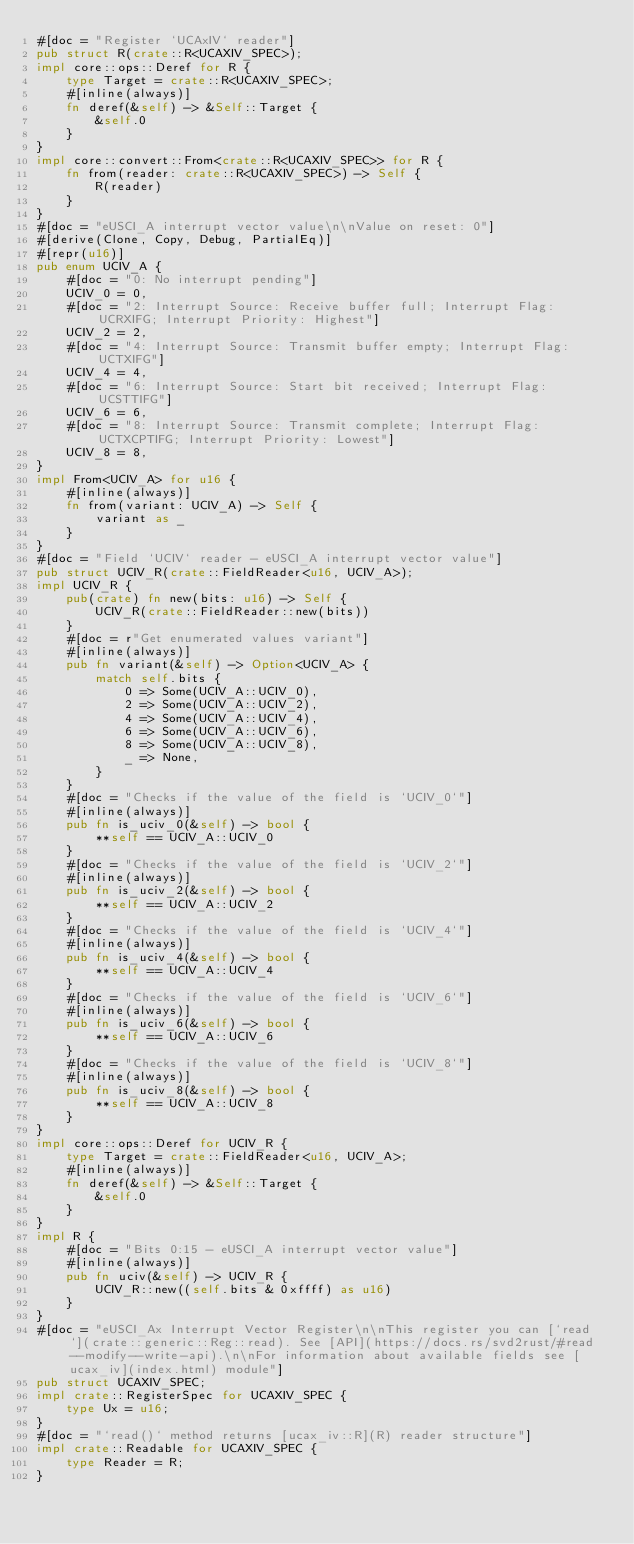Convert code to text. <code><loc_0><loc_0><loc_500><loc_500><_Rust_>#[doc = "Register `UCAxIV` reader"]
pub struct R(crate::R<UCAXIV_SPEC>);
impl core::ops::Deref for R {
    type Target = crate::R<UCAXIV_SPEC>;
    #[inline(always)]
    fn deref(&self) -> &Self::Target {
        &self.0
    }
}
impl core::convert::From<crate::R<UCAXIV_SPEC>> for R {
    fn from(reader: crate::R<UCAXIV_SPEC>) -> Self {
        R(reader)
    }
}
#[doc = "eUSCI_A interrupt vector value\n\nValue on reset: 0"]
#[derive(Clone, Copy, Debug, PartialEq)]
#[repr(u16)]
pub enum UCIV_A {
    #[doc = "0: No interrupt pending"]
    UCIV_0 = 0,
    #[doc = "2: Interrupt Source: Receive buffer full; Interrupt Flag: UCRXIFG; Interrupt Priority: Highest"]
    UCIV_2 = 2,
    #[doc = "4: Interrupt Source: Transmit buffer empty; Interrupt Flag: UCTXIFG"]
    UCIV_4 = 4,
    #[doc = "6: Interrupt Source: Start bit received; Interrupt Flag: UCSTTIFG"]
    UCIV_6 = 6,
    #[doc = "8: Interrupt Source: Transmit complete; Interrupt Flag: UCTXCPTIFG; Interrupt Priority: Lowest"]
    UCIV_8 = 8,
}
impl From<UCIV_A> for u16 {
    #[inline(always)]
    fn from(variant: UCIV_A) -> Self {
        variant as _
    }
}
#[doc = "Field `UCIV` reader - eUSCI_A interrupt vector value"]
pub struct UCIV_R(crate::FieldReader<u16, UCIV_A>);
impl UCIV_R {
    pub(crate) fn new(bits: u16) -> Self {
        UCIV_R(crate::FieldReader::new(bits))
    }
    #[doc = r"Get enumerated values variant"]
    #[inline(always)]
    pub fn variant(&self) -> Option<UCIV_A> {
        match self.bits {
            0 => Some(UCIV_A::UCIV_0),
            2 => Some(UCIV_A::UCIV_2),
            4 => Some(UCIV_A::UCIV_4),
            6 => Some(UCIV_A::UCIV_6),
            8 => Some(UCIV_A::UCIV_8),
            _ => None,
        }
    }
    #[doc = "Checks if the value of the field is `UCIV_0`"]
    #[inline(always)]
    pub fn is_uciv_0(&self) -> bool {
        **self == UCIV_A::UCIV_0
    }
    #[doc = "Checks if the value of the field is `UCIV_2`"]
    #[inline(always)]
    pub fn is_uciv_2(&self) -> bool {
        **self == UCIV_A::UCIV_2
    }
    #[doc = "Checks if the value of the field is `UCIV_4`"]
    #[inline(always)]
    pub fn is_uciv_4(&self) -> bool {
        **self == UCIV_A::UCIV_4
    }
    #[doc = "Checks if the value of the field is `UCIV_6`"]
    #[inline(always)]
    pub fn is_uciv_6(&self) -> bool {
        **self == UCIV_A::UCIV_6
    }
    #[doc = "Checks if the value of the field is `UCIV_8`"]
    #[inline(always)]
    pub fn is_uciv_8(&self) -> bool {
        **self == UCIV_A::UCIV_8
    }
}
impl core::ops::Deref for UCIV_R {
    type Target = crate::FieldReader<u16, UCIV_A>;
    #[inline(always)]
    fn deref(&self) -> &Self::Target {
        &self.0
    }
}
impl R {
    #[doc = "Bits 0:15 - eUSCI_A interrupt vector value"]
    #[inline(always)]
    pub fn uciv(&self) -> UCIV_R {
        UCIV_R::new((self.bits & 0xffff) as u16)
    }
}
#[doc = "eUSCI_Ax Interrupt Vector Register\n\nThis register you can [`read`](crate::generic::Reg::read). See [API](https://docs.rs/svd2rust/#read--modify--write-api).\n\nFor information about available fields see [ucax_iv](index.html) module"]
pub struct UCAXIV_SPEC;
impl crate::RegisterSpec for UCAXIV_SPEC {
    type Ux = u16;
}
#[doc = "`read()` method returns [ucax_iv::R](R) reader structure"]
impl crate::Readable for UCAXIV_SPEC {
    type Reader = R;
}</code> 